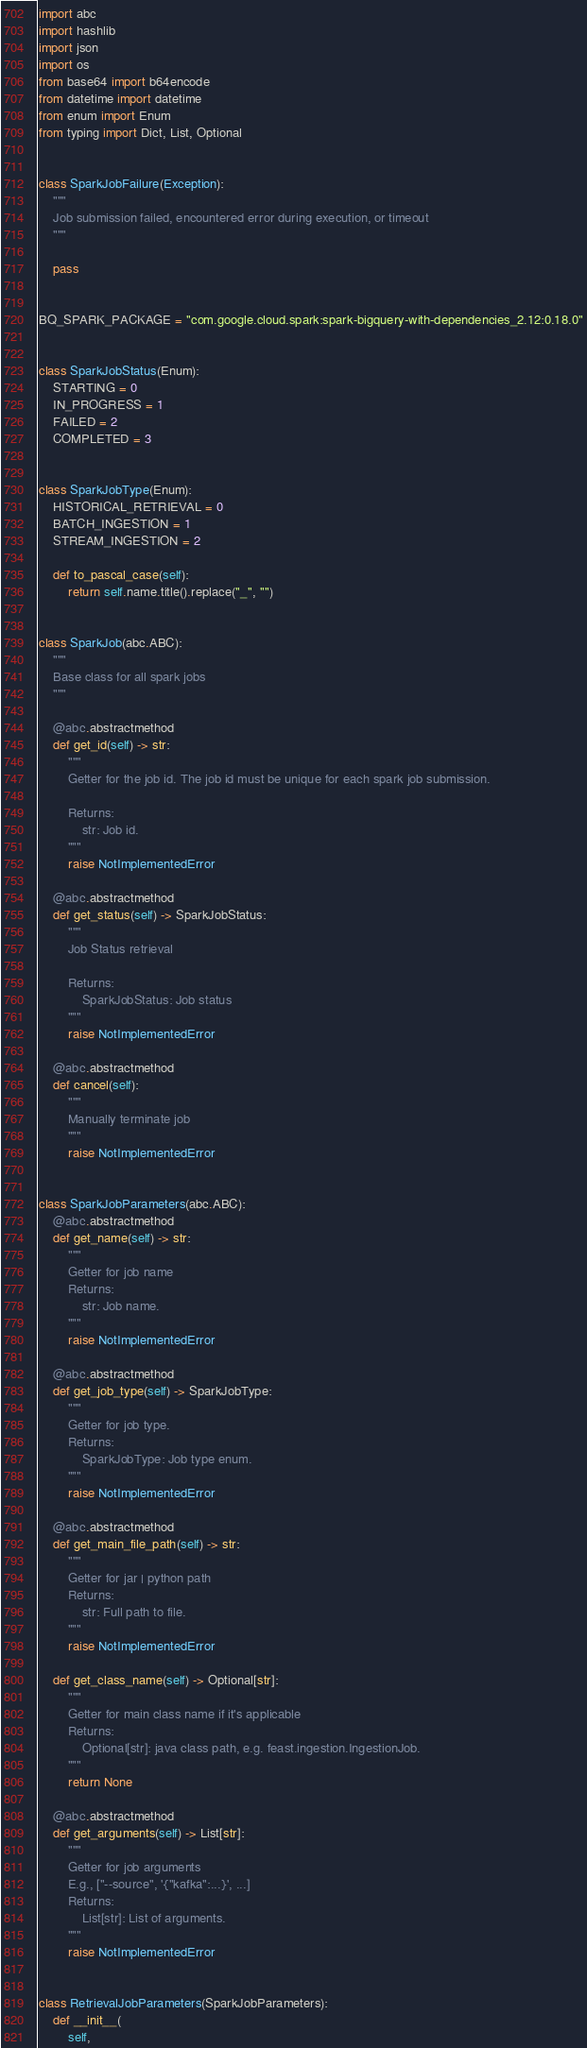<code> <loc_0><loc_0><loc_500><loc_500><_Python_>import abc
import hashlib
import json
import os
from base64 import b64encode
from datetime import datetime
from enum import Enum
from typing import Dict, List, Optional


class SparkJobFailure(Exception):
    """
    Job submission failed, encountered error during execution, or timeout
    """

    pass


BQ_SPARK_PACKAGE = "com.google.cloud.spark:spark-bigquery-with-dependencies_2.12:0.18.0"


class SparkJobStatus(Enum):
    STARTING = 0
    IN_PROGRESS = 1
    FAILED = 2
    COMPLETED = 3


class SparkJobType(Enum):
    HISTORICAL_RETRIEVAL = 0
    BATCH_INGESTION = 1
    STREAM_INGESTION = 2

    def to_pascal_case(self):
        return self.name.title().replace("_", "")


class SparkJob(abc.ABC):
    """
    Base class for all spark jobs
    """

    @abc.abstractmethod
    def get_id(self) -> str:
        """
        Getter for the job id. The job id must be unique for each spark job submission.

        Returns:
            str: Job id.
        """
        raise NotImplementedError

    @abc.abstractmethod
    def get_status(self) -> SparkJobStatus:
        """
        Job Status retrieval

        Returns:
            SparkJobStatus: Job status
        """
        raise NotImplementedError

    @abc.abstractmethod
    def cancel(self):
        """
        Manually terminate job
        """
        raise NotImplementedError


class SparkJobParameters(abc.ABC):
    @abc.abstractmethod
    def get_name(self) -> str:
        """
        Getter for job name
        Returns:
            str: Job name.
        """
        raise NotImplementedError

    @abc.abstractmethod
    def get_job_type(self) -> SparkJobType:
        """
        Getter for job type.
        Returns:
            SparkJobType: Job type enum.
        """
        raise NotImplementedError

    @abc.abstractmethod
    def get_main_file_path(self) -> str:
        """
        Getter for jar | python path
        Returns:
            str: Full path to file.
        """
        raise NotImplementedError

    def get_class_name(self) -> Optional[str]:
        """
        Getter for main class name if it's applicable
        Returns:
            Optional[str]: java class path, e.g. feast.ingestion.IngestionJob.
        """
        return None

    @abc.abstractmethod
    def get_arguments(self) -> List[str]:
        """
        Getter for job arguments
        E.g., ["--source", '{"kafka":...}', ...]
        Returns:
            List[str]: List of arguments.
        """
        raise NotImplementedError


class RetrievalJobParameters(SparkJobParameters):
    def __init__(
        self,</code> 